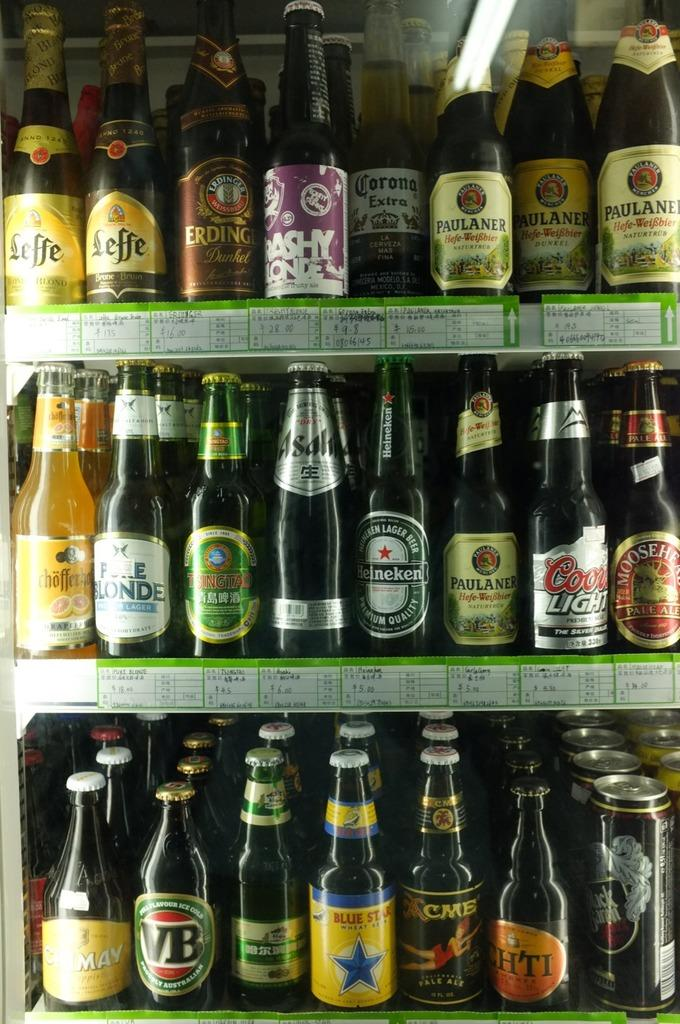What is the main subject of the image? The main subject of the image is a group of wine bottles. Can you describe the wine bottles in more detail? Yes, the wine bottles have labels on them. Are there any other people or objects visible in the image? Yes, there are kids in the back of the image. What type of rock can be seen in the image? There is no rock present in the image; it features a group of wine bottles and kids. How many kittens are playing with the wine bottles in the image? There are no kittens present in the image. 